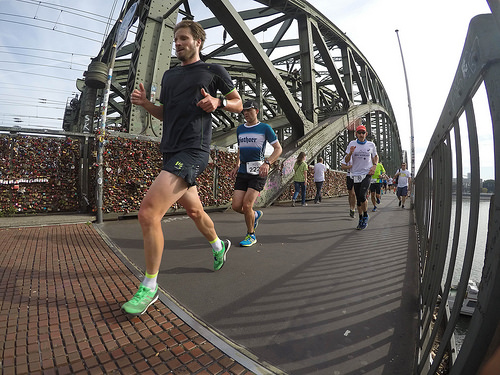<image>
Is the man behind the man? Yes. From this viewpoint, the man is positioned behind the man, with the man partially or fully occluding the man. Where is the man in relation to the ground? Is it above the ground? Yes. The man is positioned above the ground in the vertical space, higher up in the scene. 